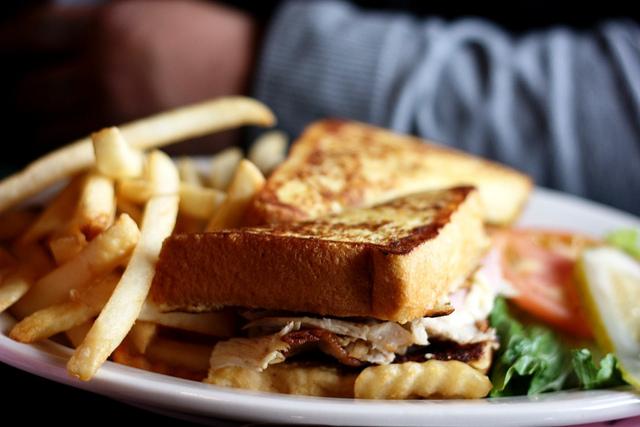How many vegetables are on the plate?
Be succinct. 3. Is this a healthy meal?
Give a very brief answer. No. Is the bread toasted?
Give a very brief answer. Yes. 